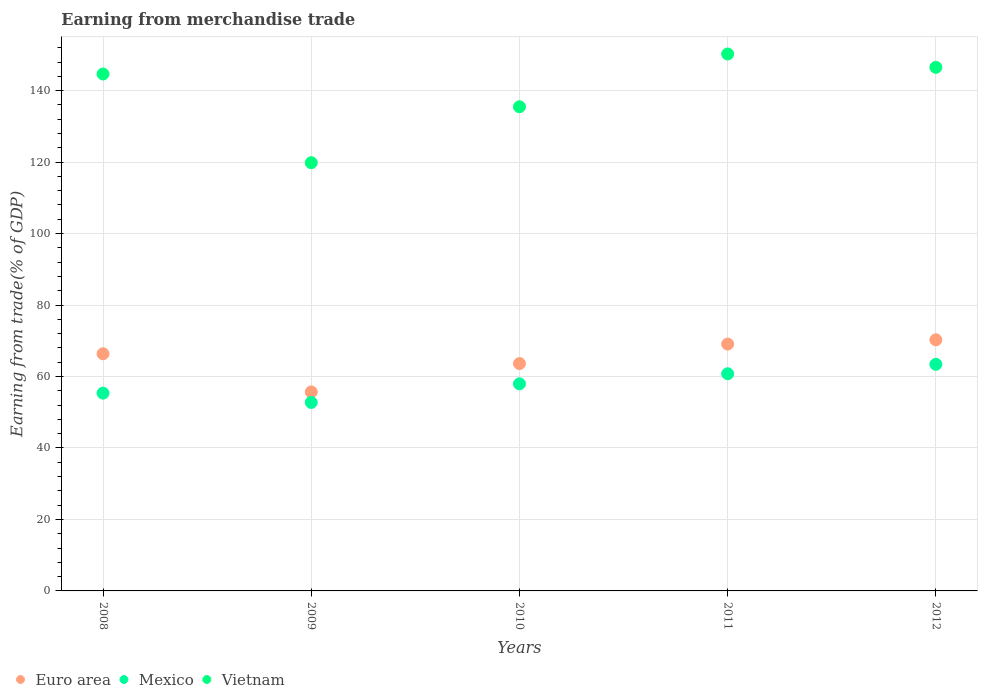How many different coloured dotlines are there?
Your response must be concise. 3. Is the number of dotlines equal to the number of legend labels?
Offer a terse response. Yes. What is the earnings from trade in Vietnam in 2011?
Give a very brief answer. 150.26. Across all years, what is the maximum earnings from trade in Vietnam?
Ensure brevity in your answer.  150.26. Across all years, what is the minimum earnings from trade in Mexico?
Ensure brevity in your answer.  52.75. What is the total earnings from trade in Euro area in the graph?
Provide a short and direct response. 325.04. What is the difference between the earnings from trade in Vietnam in 2009 and that in 2010?
Offer a very short reply. -15.65. What is the difference between the earnings from trade in Mexico in 2010 and the earnings from trade in Vietnam in 2012?
Make the answer very short. -88.56. What is the average earnings from trade in Mexico per year?
Keep it short and to the point. 58.05. In the year 2008, what is the difference between the earnings from trade in Euro area and earnings from trade in Mexico?
Provide a succinct answer. 11.01. In how many years, is the earnings from trade in Mexico greater than 88 %?
Ensure brevity in your answer.  0. What is the ratio of the earnings from trade in Vietnam in 2008 to that in 2010?
Provide a succinct answer. 1.07. What is the difference between the highest and the second highest earnings from trade in Mexico?
Offer a terse response. 2.64. What is the difference between the highest and the lowest earnings from trade in Vietnam?
Offer a terse response. 30.42. Is it the case that in every year, the sum of the earnings from trade in Mexico and earnings from trade in Euro area  is greater than the earnings from trade in Vietnam?
Your response must be concise. No. Does the earnings from trade in Mexico monotonically increase over the years?
Keep it short and to the point. No. Is the earnings from trade in Mexico strictly greater than the earnings from trade in Vietnam over the years?
Your answer should be compact. No. Is the earnings from trade in Vietnam strictly less than the earnings from trade in Mexico over the years?
Make the answer very short. No. How many dotlines are there?
Give a very brief answer. 3. How many years are there in the graph?
Offer a terse response. 5. What is the difference between two consecutive major ticks on the Y-axis?
Provide a short and direct response. 20. Does the graph contain any zero values?
Ensure brevity in your answer.  No. Where does the legend appear in the graph?
Give a very brief answer. Bottom left. How many legend labels are there?
Provide a succinct answer. 3. What is the title of the graph?
Your answer should be very brief. Earning from merchandise trade. What is the label or title of the X-axis?
Your response must be concise. Years. What is the label or title of the Y-axis?
Give a very brief answer. Earning from trade(% of GDP). What is the Earning from trade(% of GDP) in Euro area in 2008?
Your answer should be compact. 66.36. What is the Earning from trade(% of GDP) of Mexico in 2008?
Your answer should be compact. 55.35. What is the Earning from trade(% of GDP) of Vietnam in 2008?
Provide a short and direct response. 144.66. What is the Earning from trade(% of GDP) of Euro area in 2009?
Offer a terse response. 55.69. What is the Earning from trade(% of GDP) in Mexico in 2009?
Offer a very short reply. 52.75. What is the Earning from trade(% of GDP) of Vietnam in 2009?
Offer a terse response. 119.84. What is the Earning from trade(% of GDP) in Euro area in 2010?
Provide a succinct answer. 63.63. What is the Earning from trade(% of GDP) in Mexico in 2010?
Offer a terse response. 57.96. What is the Earning from trade(% of GDP) in Vietnam in 2010?
Provide a short and direct response. 135.49. What is the Earning from trade(% of GDP) of Euro area in 2011?
Provide a succinct answer. 69.08. What is the Earning from trade(% of GDP) of Mexico in 2011?
Keep it short and to the point. 60.77. What is the Earning from trade(% of GDP) in Vietnam in 2011?
Your answer should be compact. 150.26. What is the Earning from trade(% of GDP) of Euro area in 2012?
Give a very brief answer. 70.27. What is the Earning from trade(% of GDP) in Mexico in 2012?
Make the answer very short. 63.41. What is the Earning from trade(% of GDP) of Vietnam in 2012?
Your answer should be compact. 146.52. Across all years, what is the maximum Earning from trade(% of GDP) in Euro area?
Provide a short and direct response. 70.27. Across all years, what is the maximum Earning from trade(% of GDP) in Mexico?
Your answer should be compact. 63.41. Across all years, what is the maximum Earning from trade(% of GDP) in Vietnam?
Provide a short and direct response. 150.26. Across all years, what is the minimum Earning from trade(% of GDP) in Euro area?
Your response must be concise. 55.69. Across all years, what is the minimum Earning from trade(% of GDP) in Mexico?
Provide a succinct answer. 52.75. Across all years, what is the minimum Earning from trade(% of GDP) of Vietnam?
Provide a succinct answer. 119.84. What is the total Earning from trade(% of GDP) in Euro area in the graph?
Make the answer very short. 325.04. What is the total Earning from trade(% of GDP) of Mexico in the graph?
Offer a very short reply. 290.24. What is the total Earning from trade(% of GDP) of Vietnam in the graph?
Your answer should be compact. 696.76. What is the difference between the Earning from trade(% of GDP) in Euro area in 2008 and that in 2009?
Your answer should be compact. 10.67. What is the difference between the Earning from trade(% of GDP) of Mexico in 2008 and that in 2009?
Ensure brevity in your answer.  2.6. What is the difference between the Earning from trade(% of GDP) in Vietnam in 2008 and that in 2009?
Provide a short and direct response. 24.82. What is the difference between the Earning from trade(% of GDP) of Euro area in 2008 and that in 2010?
Your answer should be compact. 2.73. What is the difference between the Earning from trade(% of GDP) in Mexico in 2008 and that in 2010?
Your response must be concise. -2.61. What is the difference between the Earning from trade(% of GDP) in Vietnam in 2008 and that in 2010?
Keep it short and to the point. 9.17. What is the difference between the Earning from trade(% of GDP) of Euro area in 2008 and that in 2011?
Provide a succinct answer. -2.72. What is the difference between the Earning from trade(% of GDP) of Mexico in 2008 and that in 2011?
Provide a succinct answer. -5.42. What is the difference between the Earning from trade(% of GDP) in Vietnam in 2008 and that in 2011?
Your answer should be compact. -5.6. What is the difference between the Earning from trade(% of GDP) of Euro area in 2008 and that in 2012?
Your answer should be very brief. -3.91. What is the difference between the Earning from trade(% of GDP) in Mexico in 2008 and that in 2012?
Provide a succinct answer. -8.06. What is the difference between the Earning from trade(% of GDP) in Vietnam in 2008 and that in 2012?
Give a very brief answer. -1.86. What is the difference between the Earning from trade(% of GDP) in Euro area in 2009 and that in 2010?
Provide a succinct answer. -7.94. What is the difference between the Earning from trade(% of GDP) in Mexico in 2009 and that in 2010?
Provide a short and direct response. -5.21. What is the difference between the Earning from trade(% of GDP) in Vietnam in 2009 and that in 2010?
Your answer should be compact. -15.65. What is the difference between the Earning from trade(% of GDP) in Euro area in 2009 and that in 2011?
Make the answer very short. -13.39. What is the difference between the Earning from trade(% of GDP) of Mexico in 2009 and that in 2011?
Give a very brief answer. -8.02. What is the difference between the Earning from trade(% of GDP) in Vietnam in 2009 and that in 2011?
Your answer should be very brief. -30.42. What is the difference between the Earning from trade(% of GDP) in Euro area in 2009 and that in 2012?
Make the answer very short. -14.58. What is the difference between the Earning from trade(% of GDP) in Mexico in 2009 and that in 2012?
Your answer should be compact. -10.67. What is the difference between the Earning from trade(% of GDP) in Vietnam in 2009 and that in 2012?
Make the answer very short. -26.68. What is the difference between the Earning from trade(% of GDP) of Euro area in 2010 and that in 2011?
Your response must be concise. -5.45. What is the difference between the Earning from trade(% of GDP) of Mexico in 2010 and that in 2011?
Your response must be concise. -2.81. What is the difference between the Earning from trade(% of GDP) of Vietnam in 2010 and that in 2011?
Provide a short and direct response. -14.77. What is the difference between the Earning from trade(% of GDP) in Euro area in 2010 and that in 2012?
Provide a short and direct response. -6.64. What is the difference between the Earning from trade(% of GDP) of Mexico in 2010 and that in 2012?
Your response must be concise. -5.45. What is the difference between the Earning from trade(% of GDP) in Vietnam in 2010 and that in 2012?
Ensure brevity in your answer.  -11.03. What is the difference between the Earning from trade(% of GDP) in Euro area in 2011 and that in 2012?
Your answer should be compact. -1.19. What is the difference between the Earning from trade(% of GDP) of Mexico in 2011 and that in 2012?
Provide a succinct answer. -2.64. What is the difference between the Earning from trade(% of GDP) of Vietnam in 2011 and that in 2012?
Offer a very short reply. 3.73. What is the difference between the Earning from trade(% of GDP) of Euro area in 2008 and the Earning from trade(% of GDP) of Mexico in 2009?
Make the answer very short. 13.62. What is the difference between the Earning from trade(% of GDP) in Euro area in 2008 and the Earning from trade(% of GDP) in Vietnam in 2009?
Offer a terse response. -53.47. What is the difference between the Earning from trade(% of GDP) of Mexico in 2008 and the Earning from trade(% of GDP) of Vietnam in 2009?
Your answer should be compact. -64.49. What is the difference between the Earning from trade(% of GDP) in Euro area in 2008 and the Earning from trade(% of GDP) in Mexico in 2010?
Ensure brevity in your answer.  8.41. What is the difference between the Earning from trade(% of GDP) of Euro area in 2008 and the Earning from trade(% of GDP) of Vietnam in 2010?
Your response must be concise. -69.13. What is the difference between the Earning from trade(% of GDP) in Mexico in 2008 and the Earning from trade(% of GDP) in Vietnam in 2010?
Make the answer very short. -80.14. What is the difference between the Earning from trade(% of GDP) in Euro area in 2008 and the Earning from trade(% of GDP) in Mexico in 2011?
Your answer should be very brief. 5.59. What is the difference between the Earning from trade(% of GDP) of Euro area in 2008 and the Earning from trade(% of GDP) of Vietnam in 2011?
Your answer should be very brief. -83.89. What is the difference between the Earning from trade(% of GDP) of Mexico in 2008 and the Earning from trade(% of GDP) of Vietnam in 2011?
Offer a terse response. -94.9. What is the difference between the Earning from trade(% of GDP) of Euro area in 2008 and the Earning from trade(% of GDP) of Mexico in 2012?
Ensure brevity in your answer.  2.95. What is the difference between the Earning from trade(% of GDP) of Euro area in 2008 and the Earning from trade(% of GDP) of Vietnam in 2012?
Offer a very short reply. -80.16. What is the difference between the Earning from trade(% of GDP) of Mexico in 2008 and the Earning from trade(% of GDP) of Vietnam in 2012?
Provide a succinct answer. -91.17. What is the difference between the Earning from trade(% of GDP) of Euro area in 2009 and the Earning from trade(% of GDP) of Mexico in 2010?
Keep it short and to the point. -2.27. What is the difference between the Earning from trade(% of GDP) of Euro area in 2009 and the Earning from trade(% of GDP) of Vietnam in 2010?
Provide a succinct answer. -79.8. What is the difference between the Earning from trade(% of GDP) of Mexico in 2009 and the Earning from trade(% of GDP) of Vietnam in 2010?
Ensure brevity in your answer.  -82.74. What is the difference between the Earning from trade(% of GDP) of Euro area in 2009 and the Earning from trade(% of GDP) of Mexico in 2011?
Your response must be concise. -5.08. What is the difference between the Earning from trade(% of GDP) in Euro area in 2009 and the Earning from trade(% of GDP) in Vietnam in 2011?
Provide a succinct answer. -94.57. What is the difference between the Earning from trade(% of GDP) in Mexico in 2009 and the Earning from trade(% of GDP) in Vietnam in 2011?
Your answer should be compact. -97.51. What is the difference between the Earning from trade(% of GDP) of Euro area in 2009 and the Earning from trade(% of GDP) of Mexico in 2012?
Give a very brief answer. -7.72. What is the difference between the Earning from trade(% of GDP) in Euro area in 2009 and the Earning from trade(% of GDP) in Vietnam in 2012?
Provide a short and direct response. -90.83. What is the difference between the Earning from trade(% of GDP) in Mexico in 2009 and the Earning from trade(% of GDP) in Vietnam in 2012?
Your answer should be very brief. -93.77. What is the difference between the Earning from trade(% of GDP) of Euro area in 2010 and the Earning from trade(% of GDP) of Mexico in 2011?
Your answer should be very brief. 2.86. What is the difference between the Earning from trade(% of GDP) of Euro area in 2010 and the Earning from trade(% of GDP) of Vietnam in 2011?
Your answer should be very brief. -86.62. What is the difference between the Earning from trade(% of GDP) in Mexico in 2010 and the Earning from trade(% of GDP) in Vietnam in 2011?
Offer a very short reply. -92.3. What is the difference between the Earning from trade(% of GDP) in Euro area in 2010 and the Earning from trade(% of GDP) in Mexico in 2012?
Offer a very short reply. 0.22. What is the difference between the Earning from trade(% of GDP) in Euro area in 2010 and the Earning from trade(% of GDP) in Vietnam in 2012?
Your answer should be compact. -82.89. What is the difference between the Earning from trade(% of GDP) in Mexico in 2010 and the Earning from trade(% of GDP) in Vietnam in 2012?
Keep it short and to the point. -88.56. What is the difference between the Earning from trade(% of GDP) in Euro area in 2011 and the Earning from trade(% of GDP) in Mexico in 2012?
Offer a very short reply. 5.67. What is the difference between the Earning from trade(% of GDP) in Euro area in 2011 and the Earning from trade(% of GDP) in Vietnam in 2012?
Your answer should be compact. -77.44. What is the difference between the Earning from trade(% of GDP) in Mexico in 2011 and the Earning from trade(% of GDP) in Vietnam in 2012?
Offer a very short reply. -85.75. What is the average Earning from trade(% of GDP) in Euro area per year?
Ensure brevity in your answer.  65.01. What is the average Earning from trade(% of GDP) of Mexico per year?
Your response must be concise. 58.05. What is the average Earning from trade(% of GDP) of Vietnam per year?
Offer a terse response. 139.35. In the year 2008, what is the difference between the Earning from trade(% of GDP) of Euro area and Earning from trade(% of GDP) of Mexico?
Make the answer very short. 11.01. In the year 2008, what is the difference between the Earning from trade(% of GDP) of Euro area and Earning from trade(% of GDP) of Vietnam?
Give a very brief answer. -78.29. In the year 2008, what is the difference between the Earning from trade(% of GDP) in Mexico and Earning from trade(% of GDP) in Vietnam?
Your answer should be compact. -89.31. In the year 2009, what is the difference between the Earning from trade(% of GDP) of Euro area and Earning from trade(% of GDP) of Mexico?
Your answer should be compact. 2.94. In the year 2009, what is the difference between the Earning from trade(% of GDP) in Euro area and Earning from trade(% of GDP) in Vietnam?
Give a very brief answer. -64.15. In the year 2009, what is the difference between the Earning from trade(% of GDP) in Mexico and Earning from trade(% of GDP) in Vietnam?
Provide a short and direct response. -67.09. In the year 2010, what is the difference between the Earning from trade(% of GDP) in Euro area and Earning from trade(% of GDP) in Mexico?
Provide a succinct answer. 5.67. In the year 2010, what is the difference between the Earning from trade(% of GDP) of Euro area and Earning from trade(% of GDP) of Vietnam?
Offer a terse response. -71.86. In the year 2010, what is the difference between the Earning from trade(% of GDP) in Mexico and Earning from trade(% of GDP) in Vietnam?
Your response must be concise. -77.53. In the year 2011, what is the difference between the Earning from trade(% of GDP) of Euro area and Earning from trade(% of GDP) of Mexico?
Ensure brevity in your answer.  8.31. In the year 2011, what is the difference between the Earning from trade(% of GDP) of Euro area and Earning from trade(% of GDP) of Vietnam?
Provide a succinct answer. -81.17. In the year 2011, what is the difference between the Earning from trade(% of GDP) of Mexico and Earning from trade(% of GDP) of Vietnam?
Ensure brevity in your answer.  -89.48. In the year 2012, what is the difference between the Earning from trade(% of GDP) in Euro area and Earning from trade(% of GDP) in Mexico?
Ensure brevity in your answer.  6.86. In the year 2012, what is the difference between the Earning from trade(% of GDP) of Euro area and Earning from trade(% of GDP) of Vietnam?
Provide a succinct answer. -76.25. In the year 2012, what is the difference between the Earning from trade(% of GDP) in Mexico and Earning from trade(% of GDP) in Vietnam?
Offer a very short reply. -83.11. What is the ratio of the Earning from trade(% of GDP) in Euro area in 2008 to that in 2009?
Offer a terse response. 1.19. What is the ratio of the Earning from trade(% of GDP) of Mexico in 2008 to that in 2009?
Make the answer very short. 1.05. What is the ratio of the Earning from trade(% of GDP) of Vietnam in 2008 to that in 2009?
Offer a very short reply. 1.21. What is the ratio of the Earning from trade(% of GDP) in Euro area in 2008 to that in 2010?
Give a very brief answer. 1.04. What is the ratio of the Earning from trade(% of GDP) of Mexico in 2008 to that in 2010?
Offer a terse response. 0.95. What is the ratio of the Earning from trade(% of GDP) of Vietnam in 2008 to that in 2010?
Offer a terse response. 1.07. What is the ratio of the Earning from trade(% of GDP) of Euro area in 2008 to that in 2011?
Your response must be concise. 0.96. What is the ratio of the Earning from trade(% of GDP) in Mexico in 2008 to that in 2011?
Ensure brevity in your answer.  0.91. What is the ratio of the Earning from trade(% of GDP) of Vietnam in 2008 to that in 2011?
Offer a very short reply. 0.96. What is the ratio of the Earning from trade(% of GDP) of Mexico in 2008 to that in 2012?
Your answer should be compact. 0.87. What is the ratio of the Earning from trade(% of GDP) in Vietnam in 2008 to that in 2012?
Provide a short and direct response. 0.99. What is the ratio of the Earning from trade(% of GDP) in Euro area in 2009 to that in 2010?
Your answer should be compact. 0.88. What is the ratio of the Earning from trade(% of GDP) of Mexico in 2009 to that in 2010?
Offer a terse response. 0.91. What is the ratio of the Earning from trade(% of GDP) in Vietnam in 2009 to that in 2010?
Your response must be concise. 0.88. What is the ratio of the Earning from trade(% of GDP) of Euro area in 2009 to that in 2011?
Your answer should be very brief. 0.81. What is the ratio of the Earning from trade(% of GDP) of Mexico in 2009 to that in 2011?
Ensure brevity in your answer.  0.87. What is the ratio of the Earning from trade(% of GDP) of Vietnam in 2009 to that in 2011?
Provide a succinct answer. 0.8. What is the ratio of the Earning from trade(% of GDP) of Euro area in 2009 to that in 2012?
Your response must be concise. 0.79. What is the ratio of the Earning from trade(% of GDP) in Mexico in 2009 to that in 2012?
Provide a succinct answer. 0.83. What is the ratio of the Earning from trade(% of GDP) in Vietnam in 2009 to that in 2012?
Keep it short and to the point. 0.82. What is the ratio of the Earning from trade(% of GDP) in Euro area in 2010 to that in 2011?
Your answer should be compact. 0.92. What is the ratio of the Earning from trade(% of GDP) in Mexico in 2010 to that in 2011?
Keep it short and to the point. 0.95. What is the ratio of the Earning from trade(% of GDP) in Vietnam in 2010 to that in 2011?
Offer a terse response. 0.9. What is the ratio of the Earning from trade(% of GDP) of Euro area in 2010 to that in 2012?
Offer a very short reply. 0.91. What is the ratio of the Earning from trade(% of GDP) in Mexico in 2010 to that in 2012?
Make the answer very short. 0.91. What is the ratio of the Earning from trade(% of GDP) of Vietnam in 2010 to that in 2012?
Offer a terse response. 0.92. What is the ratio of the Earning from trade(% of GDP) of Euro area in 2011 to that in 2012?
Keep it short and to the point. 0.98. What is the ratio of the Earning from trade(% of GDP) in Mexico in 2011 to that in 2012?
Make the answer very short. 0.96. What is the ratio of the Earning from trade(% of GDP) in Vietnam in 2011 to that in 2012?
Ensure brevity in your answer.  1.03. What is the difference between the highest and the second highest Earning from trade(% of GDP) in Euro area?
Your answer should be very brief. 1.19. What is the difference between the highest and the second highest Earning from trade(% of GDP) of Mexico?
Your answer should be very brief. 2.64. What is the difference between the highest and the second highest Earning from trade(% of GDP) in Vietnam?
Your answer should be very brief. 3.73. What is the difference between the highest and the lowest Earning from trade(% of GDP) in Euro area?
Make the answer very short. 14.58. What is the difference between the highest and the lowest Earning from trade(% of GDP) of Mexico?
Ensure brevity in your answer.  10.67. What is the difference between the highest and the lowest Earning from trade(% of GDP) of Vietnam?
Make the answer very short. 30.42. 